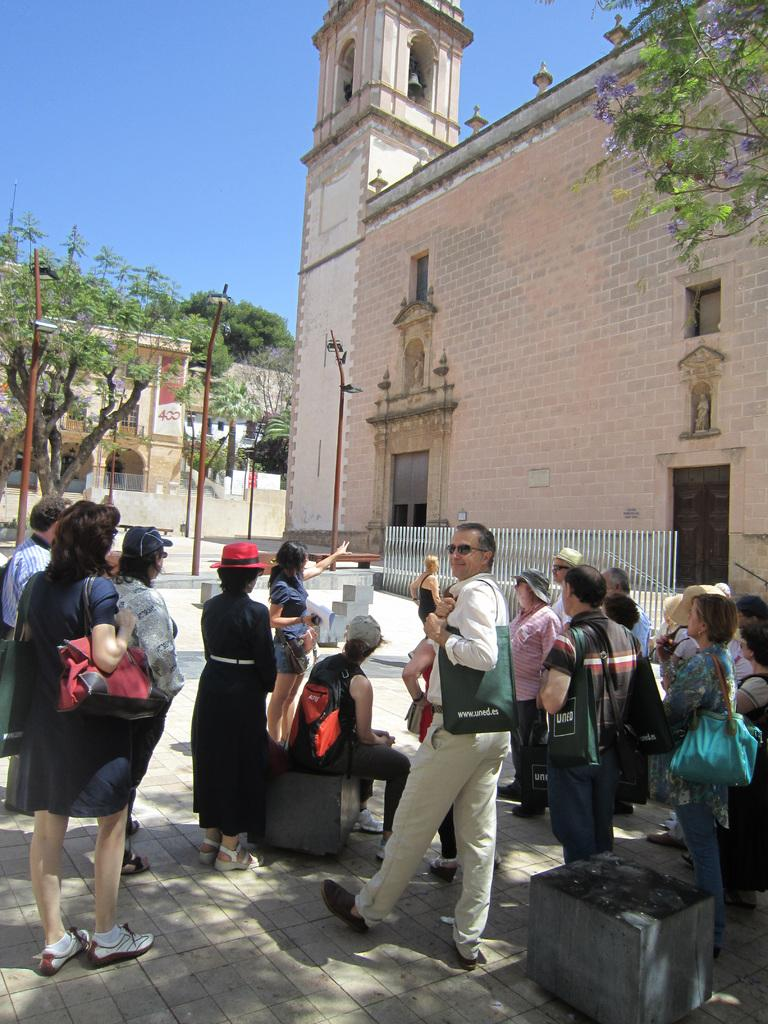What is happening with the group of people in the image? There is a group of people on the ground in the image. What are some people in the group wearing? Some people in the group are wearing bags. What can be seen in the background of the image? There are buildings, trees, poles, and the sky visible in the background of the image. Can you tell me how many frogs are sitting on the leaves in the image? There are no frogs or leaves present in the image; it features a group of people on the ground with a background of buildings, trees, poles, and the sky. 